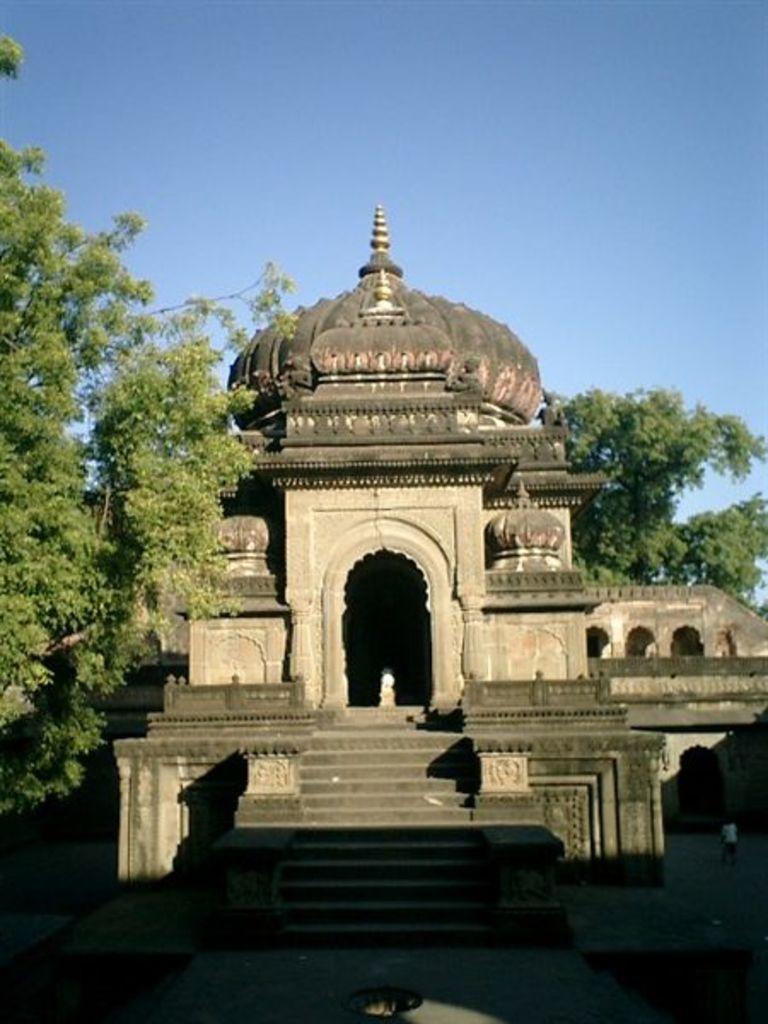Can you describe this image briefly? In this image we can see a monument. There are few trees in the image. There is a clear and blue sky in the image. 